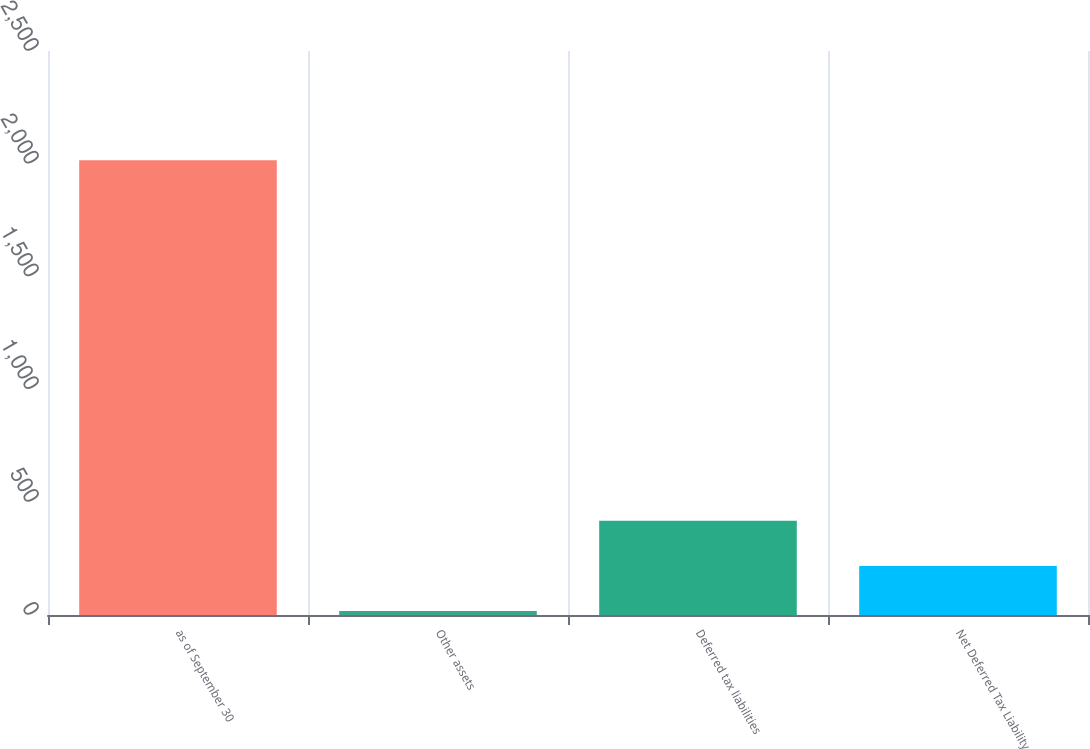Convert chart to OTSL. <chart><loc_0><loc_0><loc_500><loc_500><bar_chart><fcel>as of September 30<fcel>Other assets<fcel>Deferred tax liabilities<fcel>Net Deferred Tax Liability<nl><fcel>2016<fcel>17.7<fcel>417.36<fcel>217.53<nl></chart> 